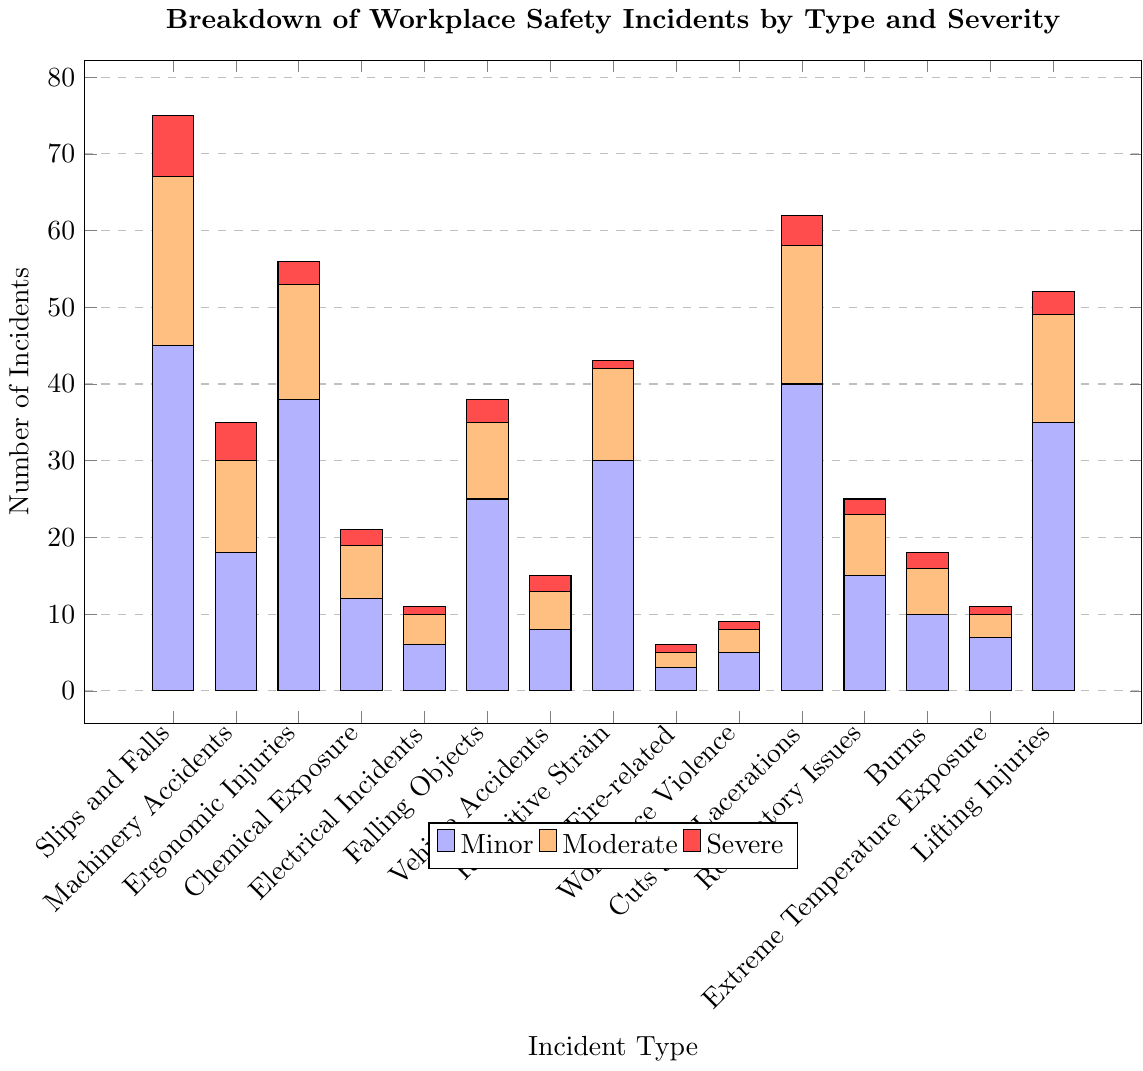Which incident type has the highest number of minor incidents? The chart shows bars of different heights for each incident type under the category 'Minor'. The highest bar represents Slips and Falls with 45 minor incidents.
Answer: Slips and Falls Which incident type has the lowest number of severe incidents? The chart shows the number of severe incidents with red bars. Fire-related, Workplace Violence, Extreme Temperature Exposure, and Electrical Incidents all have the lowest number of severe incidents with 1 each.
Answer: Fire-related, Workplace Violence, Extreme Temperature Exposure, Electrical Incidents How many moderate incidents are there for Ergonomic Injuries and Lifting Injuries combined? To find the total, sum the moderate incidents (orange bars) for both Ergonomic Injuries and Lifting Injuries. Ergonomic Injuries have 15 moderate incidents and Lifting Injuries have 14. 15 + 14 = 29.
Answer: 29 Which incident type has more incidents in the moderate category: Repetitive Strain or Electrical Incidents? By comparing the heights of the orange bars for Repetitive Strain and Electrical Incidents, Repetitive Strain has 12 and Electrical Incidents have 4 moderate incidents.
Answer: Repetitive Strain What is the total number of incidents (minor, moderate, and severe) for Machinery Accidents? Add all types of incidents for Machinery Accidents (18 minor + 12 moderate + 5 severe). 18 + 12 + 5 = 35.
Answer: 35 Are there more minor incidents for Chemical Exposure or Fire-related incidents? By comparing the blue bars for Chemical Exposure and Fire-related incidents, Chemical Exposure has 12 minor incidents, while Fire-related has 3.
Answer: Chemical Exposure What is the difference in the total number of incidents between Slips and Falls and Vehicle Accidents? Calculate the total incidents for both types. Slips and Falls: 45 + 22 + 8 = 75. Vehicle Accidents: 8 + 5 + 2 = 15. Difference: 75 - 15 = 60.
Answer: 60 Which incident type has nearly equal numbers of minor and moderate incidents? By visually inspecting the bars, Electrical Incidents have 6 minor and 4 moderate incidents, the numbers are close compared to other incident types.
Answer: Electrical Incidents For which incident type are the severe incidents greater than the moderate incidents? By comparing the height of red and orange bars for each incident type, no incident type has severe incidents greater than moderate incidents.
Answer: None What is the average number of minor incidents across all incident types? Sum all minor incidents and divide by the number of incident types. (45 + 18 + 38 + 12 + 6 + 25 + 8 + 30 + 3 + 5 + 40 + 15 + 10 + 7 + 35) / 15 = 297 / 15 = 19.8.
Answer: 19.8 